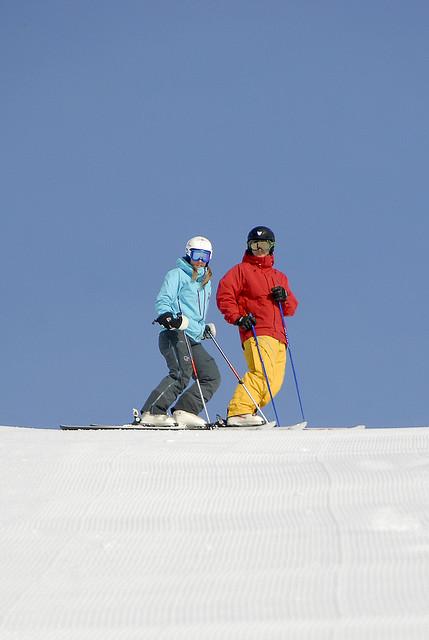What color is the person's pants on the right?
Be succinct. Yellow. What activity are these people doing?
Write a very short answer. Skiing. What covers the ground?
Write a very short answer. Snow. Are these people up high?
Keep it brief. Yes. 